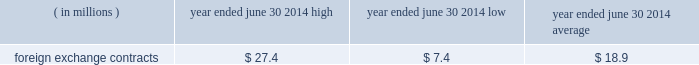Version 5 2022 9/11/14 2022 last revised by : saul bernstein 68 the est{e lauder companies inc .
Correlations calculated over the past 250-day period .
The high , low and average measured value-at-risk during fiscal 2014 related to our foreign exchange contracts is as follows: .
Foreign exchange contracts $ 27.4 $ 7.4 $ 18.9 the model estimates were made assuming normal market conditions and a 95 percent confidence level .
We used a statistical simulation model that valued our derivative financial instruments against one thousand randomly gen- erated market price paths .
Our calculated value-at-risk exposure represents an estimate of reasonably possible net losses that would be recognized on our portfolio of derivative financial instruments assuming hypothetical movements in future market rates and is not necessarily indicative of actual results , which may or may not occur .
It does not represent the maximum possible loss or any expected loss that may occur , since actual future gains and losses will differ from those estimated , based upon actual fluctuations in market rates , operating exposures , and the timing thereof , and changes in our portfolio of derivative financial instruments during the year .
We believe , however , that any such loss incurred would be offset by the effects of market rate movements on the respective underlying transactions for which the deriva- tive financial instrument was intended .
Off-balance sheet arrangements we do not maintain any off-balance sheet arrangements , transactions , obligations or other relationships with unconsolidated entities , other than operating leases , that would be expected to have a material current or future effect upon our financial condition or results of operations .
Recently issued accounting standards refer to 201cnote 2 2014 summary of significant accounting policies 201d of notes to consolidated financial statements for discussion regarding the impact of accounting stan- dards that were recently issued but not yet effective , on our consolidated financial statements .
Forward-looking information we and our representatives from time to time make written or oral forward-looking statements , including statements contained in this and other filings with the securities and exchange commission , in our press releases and in our reports to stockholders .
The words and phrases 201cwill likely result , 201d 201cexpect , 201d 201cbelieve , 201d 201cplanned , 201d 201cmay , 201d 201cshould , 201d 201ccould , 201d 201canticipate , 201d 201cestimate , 201d 201cproject , 201d 201cintend , 201d 201cforecast 201d or similar expressions are intended to identify 201cforward-looking statements 201d within the meaning of the private securities litigation reform act of 1995 .
These statements include , without limitation , our expectations regarding sales , earn- ings or other future financial performance and liquidity , product introductions , entry into new geographic regions , information systems initiatives , new methods of sale , our long-term strategy , restructuring and other charges and resulting cost savings , and future operations or operating results .
Although we believe that our expectations are based on reasonable assumptions within the bounds of our knowledge of our business and operations , actual results may differ materially from our expectations .
Factors that could cause actual results to differ from expectations include , without limitation : ( 1 ) increased competitive activity from companies in the skin care , makeup , fragrance and hair care businesses , some of which have greater resources than we do ; ( 2 ) our ability to develop , produce and market new prod- ucts on which future operating results may depend and to successfully address challenges in our business ; ( 3 ) consolidations , restructurings , bankruptcies and reorganizations in the retail industry causing a decrease in the number of stores that sell our products , an increase in the ownership concentration within the retail industry , ownership of retailers by our competitors or ownership of competitors by our customers that are retailers and our inability to collect receivables ; ( 4 ) destocking and tighter working capital management by retailers ; ( 5 ) the success , or changes in timing or scope , of new product launches and the success , or changes in the tim- ing or the scope , of advertising , sampling and merchan- dising programs ; ( 6 ) shifts in the preferences of consumers as to where and how they shop for the types of products and services we sell ; ( 7 ) social , political and economic risks to our foreign or domestic manufacturing , distribution and retail opera- tions , including changes in foreign investment and trade policies and regulations of the host countries and of the united states ; 77840es_fin.indd 68 9/12/14 5:11 pm .
What is the variation observed in the high and average foreign exchange contracts , in millions of dollars? 
Rationale: it is the difference between those values .
Computations: (27.4 - 18.9)
Answer: 8.5. 